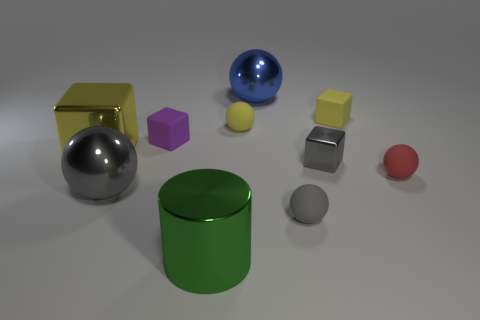Subtract all gray spheres. How many spheres are left? 3 Subtract all big gray spheres. How many spheres are left? 4 Subtract all cyan spheres. Subtract all brown cubes. How many spheres are left? 5 Subtract all cylinders. How many objects are left? 9 Add 4 big yellow blocks. How many big yellow blocks are left? 5 Add 7 big red rubber spheres. How many big red rubber spheres exist? 7 Subtract 0 purple balls. How many objects are left? 10 Subtract all small red spheres. Subtract all small shiny cubes. How many objects are left? 8 